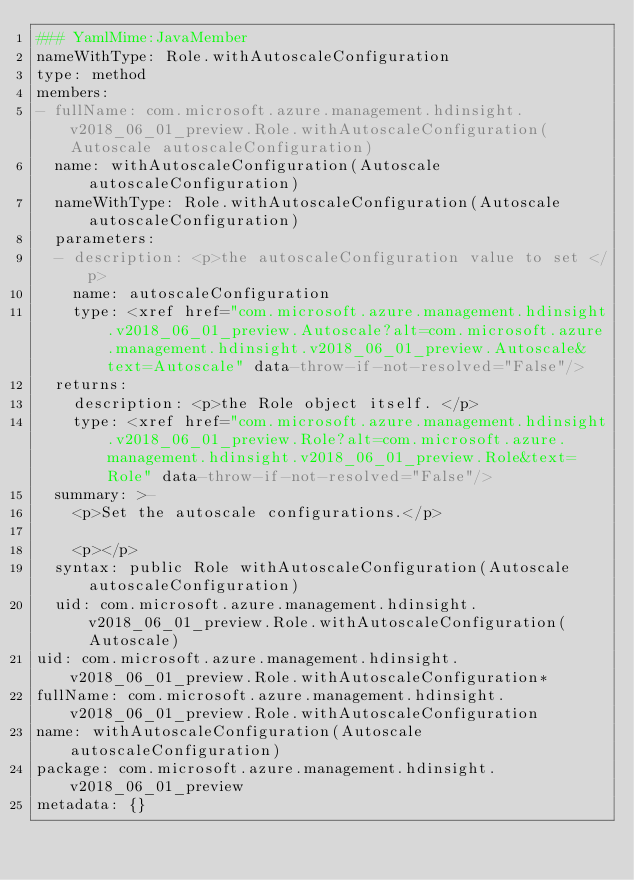<code> <loc_0><loc_0><loc_500><loc_500><_YAML_>### YamlMime:JavaMember
nameWithType: Role.withAutoscaleConfiguration
type: method
members:
- fullName: com.microsoft.azure.management.hdinsight.v2018_06_01_preview.Role.withAutoscaleConfiguration(Autoscale autoscaleConfiguration)
  name: withAutoscaleConfiguration(Autoscale autoscaleConfiguration)
  nameWithType: Role.withAutoscaleConfiguration(Autoscale autoscaleConfiguration)
  parameters:
  - description: <p>the autoscaleConfiguration value to set </p>
    name: autoscaleConfiguration
    type: <xref href="com.microsoft.azure.management.hdinsight.v2018_06_01_preview.Autoscale?alt=com.microsoft.azure.management.hdinsight.v2018_06_01_preview.Autoscale&text=Autoscale" data-throw-if-not-resolved="False"/>
  returns:
    description: <p>the Role object itself. </p>
    type: <xref href="com.microsoft.azure.management.hdinsight.v2018_06_01_preview.Role?alt=com.microsoft.azure.management.hdinsight.v2018_06_01_preview.Role&text=Role" data-throw-if-not-resolved="False"/>
  summary: >-
    <p>Set the autoscale configurations.</p>

    <p></p>
  syntax: public Role withAutoscaleConfiguration(Autoscale autoscaleConfiguration)
  uid: com.microsoft.azure.management.hdinsight.v2018_06_01_preview.Role.withAutoscaleConfiguration(Autoscale)
uid: com.microsoft.azure.management.hdinsight.v2018_06_01_preview.Role.withAutoscaleConfiguration*
fullName: com.microsoft.azure.management.hdinsight.v2018_06_01_preview.Role.withAutoscaleConfiguration
name: withAutoscaleConfiguration(Autoscale autoscaleConfiguration)
package: com.microsoft.azure.management.hdinsight.v2018_06_01_preview
metadata: {}
</code> 